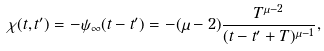Convert formula to latex. <formula><loc_0><loc_0><loc_500><loc_500>\chi ( t , t ^ { \prime } ) = - \psi _ { \infty } ( t - t ^ { \prime } ) = - ( \mu - 2 ) \frac { T ^ { \mu - 2 } } { ( t - t ^ { \prime } + T ) ^ { \mu - 1 } } ,</formula> 